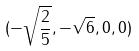<formula> <loc_0><loc_0><loc_500><loc_500>( - \sqrt { \frac { 2 } { 5 } } , - \sqrt { 6 } , 0 , 0 )</formula> 